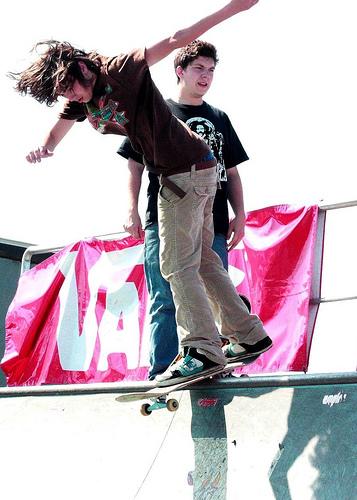What does the banner say?
Concise answer only. Vans. How many on a skateboard?
Short answer required. 1. What color is the skateboarders pants going down the ramp?
Answer briefly. Tan. 